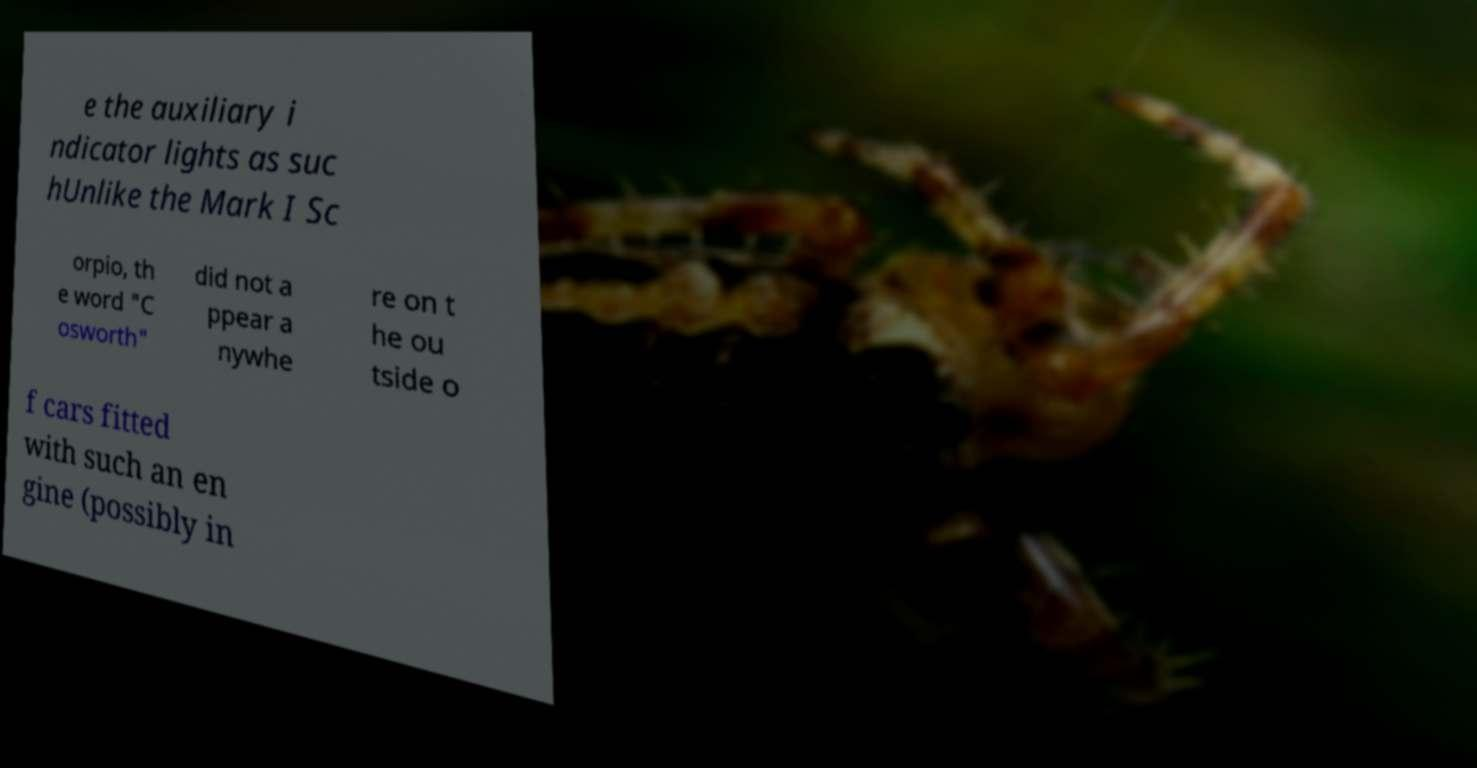Can you accurately transcribe the text from the provided image for me? e the auxiliary i ndicator lights as suc hUnlike the Mark I Sc orpio, th e word "C osworth" did not a ppear a nywhe re on t he ou tside o f cars fitted with such an en gine (possibly in 